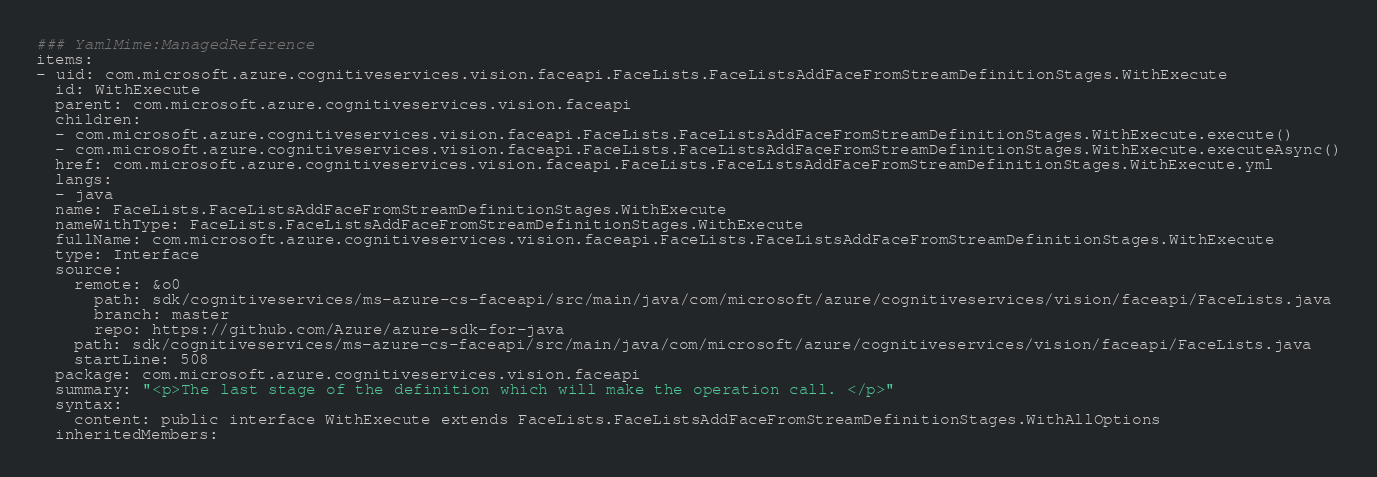<code> <loc_0><loc_0><loc_500><loc_500><_YAML_>### YamlMime:ManagedReference
items:
- uid: com.microsoft.azure.cognitiveservices.vision.faceapi.FaceLists.FaceListsAddFaceFromStreamDefinitionStages.WithExecute
  id: WithExecute
  parent: com.microsoft.azure.cognitiveservices.vision.faceapi
  children:
  - com.microsoft.azure.cognitiveservices.vision.faceapi.FaceLists.FaceListsAddFaceFromStreamDefinitionStages.WithExecute.execute()
  - com.microsoft.azure.cognitiveservices.vision.faceapi.FaceLists.FaceListsAddFaceFromStreamDefinitionStages.WithExecute.executeAsync()
  href: com.microsoft.azure.cognitiveservices.vision.faceapi.FaceLists.FaceListsAddFaceFromStreamDefinitionStages.WithExecute.yml
  langs:
  - java
  name: FaceLists.FaceListsAddFaceFromStreamDefinitionStages.WithExecute
  nameWithType: FaceLists.FaceListsAddFaceFromStreamDefinitionStages.WithExecute
  fullName: com.microsoft.azure.cognitiveservices.vision.faceapi.FaceLists.FaceListsAddFaceFromStreamDefinitionStages.WithExecute
  type: Interface
  source:
    remote: &o0
      path: sdk/cognitiveservices/ms-azure-cs-faceapi/src/main/java/com/microsoft/azure/cognitiveservices/vision/faceapi/FaceLists.java
      branch: master
      repo: https://github.com/Azure/azure-sdk-for-java
    path: sdk/cognitiveservices/ms-azure-cs-faceapi/src/main/java/com/microsoft/azure/cognitiveservices/vision/faceapi/FaceLists.java
    startLine: 508
  package: com.microsoft.azure.cognitiveservices.vision.faceapi
  summary: "<p>The last stage of the definition which will make the operation call. </p>"
  syntax:
    content: public interface WithExecute extends FaceLists.FaceListsAddFaceFromStreamDefinitionStages.WithAllOptions
  inheritedMembers:</code> 